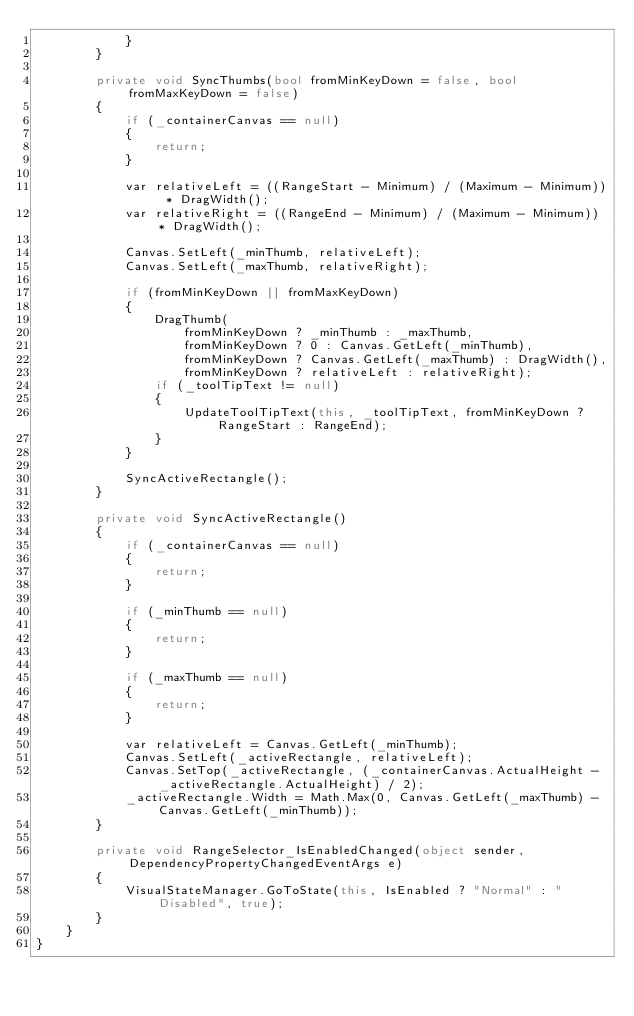<code> <loc_0><loc_0><loc_500><loc_500><_C#_>            }
        }

        private void SyncThumbs(bool fromMinKeyDown = false, bool fromMaxKeyDown = false)
        {
            if (_containerCanvas == null)
            {
                return;
            }

            var relativeLeft = ((RangeStart - Minimum) / (Maximum - Minimum)) * DragWidth();
            var relativeRight = ((RangeEnd - Minimum) / (Maximum - Minimum)) * DragWidth();

            Canvas.SetLeft(_minThumb, relativeLeft);
            Canvas.SetLeft(_maxThumb, relativeRight);

            if (fromMinKeyDown || fromMaxKeyDown)
            {
                DragThumb(
                    fromMinKeyDown ? _minThumb : _maxThumb,
                    fromMinKeyDown ? 0 : Canvas.GetLeft(_minThumb),
                    fromMinKeyDown ? Canvas.GetLeft(_maxThumb) : DragWidth(),
                    fromMinKeyDown ? relativeLeft : relativeRight);
                if (_toolTipText != null)
                {
                    UpdateToolTipText(this, _toolTipText, fromMinKeyDown ? RangeStart : RangeEnd);
                }
            }

            SyncActiveRectangle();
        }

        private void SyncActiveRectangle()
        {
            if (_containerCanvas == null)
            {
                return;
            }

            if (_minThumb == null)
            {
                return;
            }

            if (_maxThumb == null)
            {
                return;
            }

            var relativeLeft = Canvas.GetLeft(_minThumb);
            Canvas.SetLeft(_activeRectangle, relativeLeft);
            Canvas.SetTop(_activeRectangle, (_containerCanvas.ActualHeight - _activeRectangle.ActualHeight) / 2);
            _activeRectangle.Width = Math.Max(0, Canvas.GetLeft(_maxThumb) - Canvas.GetLeft(_minThumb));
        }

        private void RangeSelector_IsEnabledChanged(object sender, DependencyPropertyChangedEventArgs e)
        {
            VisualStateManager.GoToState(this, IsEnabled ? "Normal" : "Disabled", true);
        }
    }
}</code> 